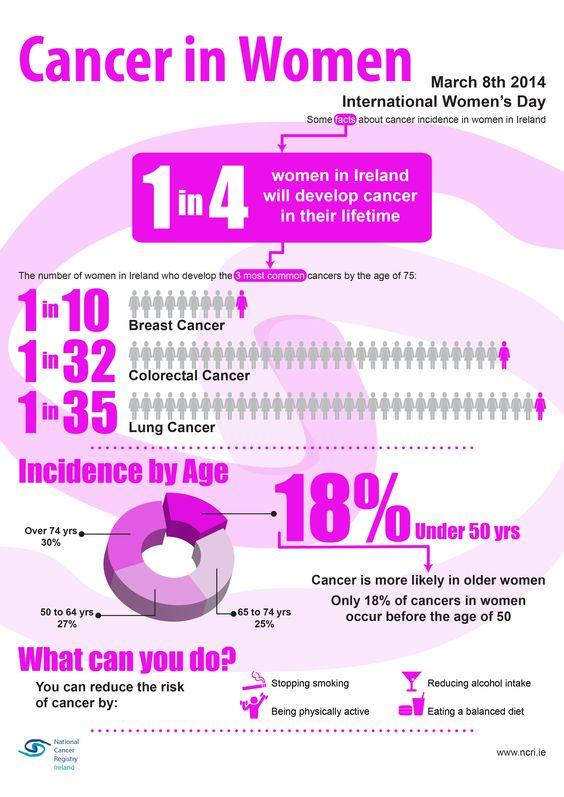Point out several critical features in this image. According to recent statistics, it is estimated that 27% of women over the age of 50 have a history of cancer. In the age group of individuals under 50 to 64 years old, approximately 45% of individuals have had incidences of cancer. 